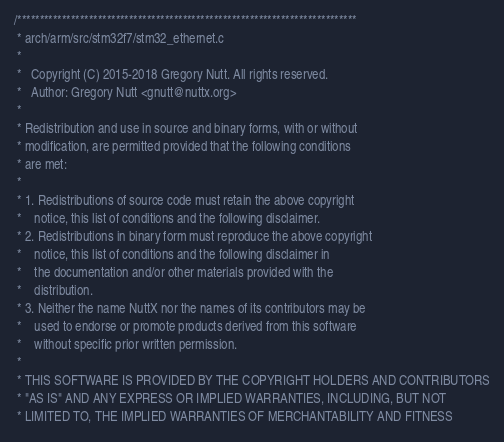<code> <loc_0><loc_0><loc_500><loc_500><_C_>/****************************************************************************
 * arch/arm/src/stm32f7/stm32_ethernet.c
 *
 *   Copyright (C) 2015-2018 Gregory Nutt. All rights reserved.
 *   Author: Gregory Nutt <gnutt@nuttx.org>
 *
 * Redistribution and use in source and binary forms, with or without
 * modification, are permitted provided that the following conditions
 * are met:
 *
 * 1. Redistributions of source code must retain the above copyright
 *    notice, this list of conditions and the following disclaimer.
 * 2. Redistributions in binary form must reproduce the above copyright
 *    notice, this list of conditions and the following disclaimer in
 *    the documentation and/or other materials provided with the
 *    distribution.
 * 3. Neither the name NuttX nor the names of its contributors may be
 *    used to endorse or promote products derived from this software
 *    without specific prior written permission.
 *
 * THIS SOFTWARE IS PROVIDED BY THE COPYRIGHT HOLDERS AND CONTRIBUTORS
 * "AS IS" AND ANY EXPRESS OR IMPLIED WARRANTIES, INCLUDING, BUT NOT
 * LIMITED TO, THE IMPLIED WARRANTIES OF MERCHANTABILITY AND FITNESS</code> 